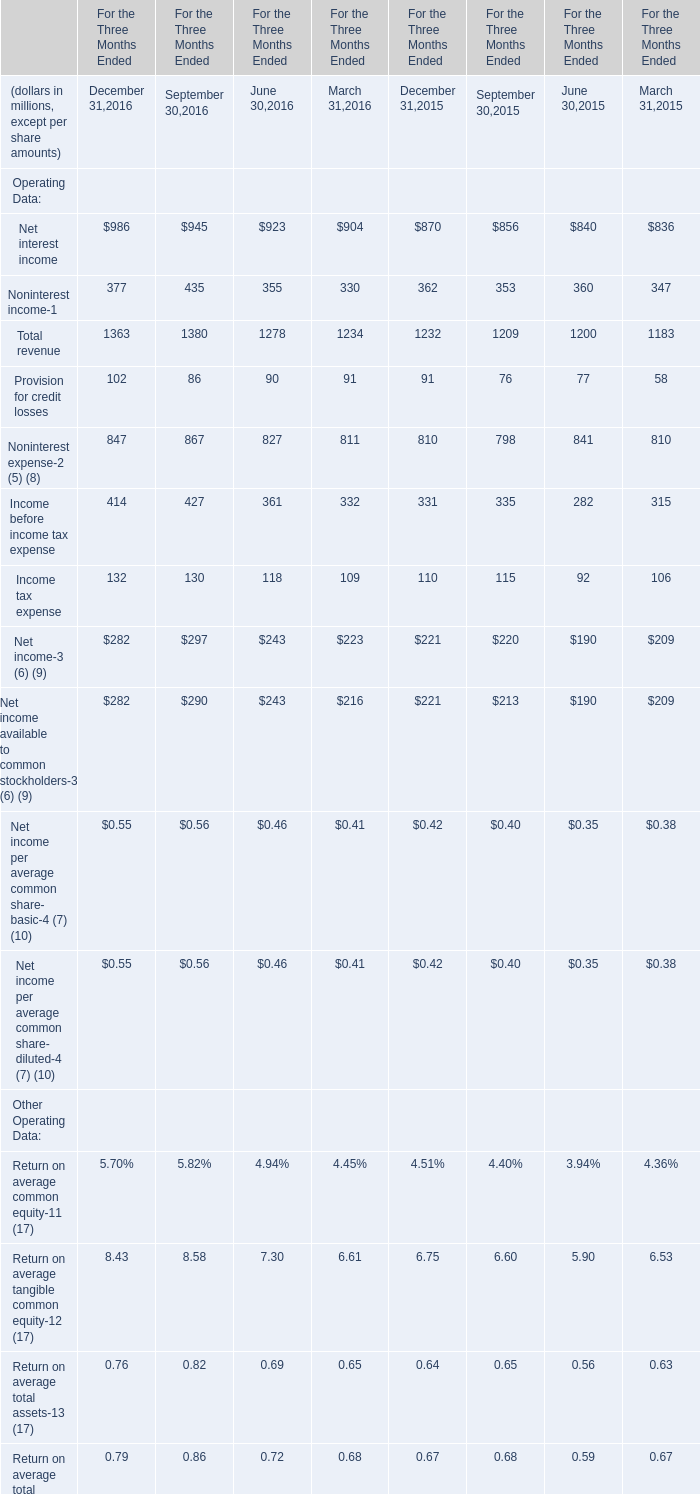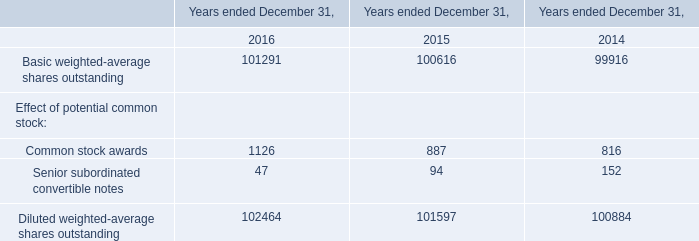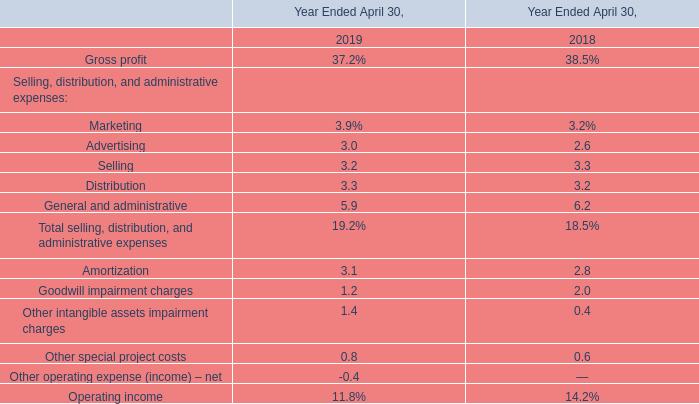What was the total amount of Net interest income in 2016 ? (in million) 
Computations: (((986 + 945) + 923) + 904)
Answer: 3758.0. 